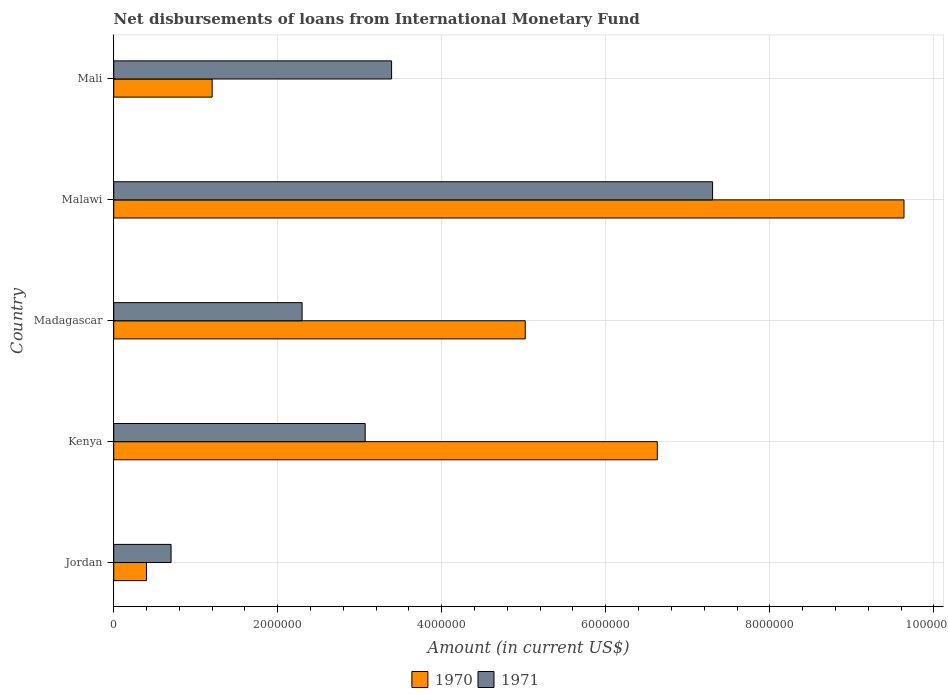How many groups of bars are there?
Make the answer very short. 5. Are the number of bars on each tick of the Y-axis equal?
Provide a succinct answer. Yes. How many bars are there on the 5th tick from the bottom?
Make the answer very short. 2. What is the label of the 1st group of bars from the top?
Give a very brief answer. Mali. In how many cases, is the number of bars for a given country not equal to the number of legend labels?
Ensure brevity in your answer.  0. What is the amount of loans disbursed in 1971 in Jordan?
Your response must be concise. 6.99e+05. Across all countries, what is the maximum amount of loans disbursed in 1970?
Offer a very short reply. 9.64e+06. Across all countries, what is the minimum amount of loans disbursed in 1971?
Your answer should be compact. 6.99e+05. In which country was the amount of loans disbursed in 1971 maximum?
Your answer should be compact. Malawi. In which country was the amount of loans disbursed in 1970 minimum?
Your answer should be compact. Jordan. What is the total amount of loans disbursed in 1971 in the graph?
Your answer should be compact. 1.68e+07. What is the difference between the amount of loans disbursed in 1971 in Jordan and that in Kenya?
Provide a short and direct response. -2.37e+06. What is the difference between the amount of loans disbursed in 1970 in Mali and the amount of loans disbursed in 1971 in Kenya?
Make the answer very short. -1.87e+06. What is the average amount of loans disbursed in 1971 per country?
Keep it short and to the point. 3.35e+06. What is the difference between the amount of loans disbursed in 1970 and amount of loans disbursed in 1971 in Madagascar?
Give a very brief answer. 2.72e+06. In how many countries, is the amount of loans disbursed in 1971 greater than 400000 US$?
Your response must be concise. 5. What is the ratio of the amount of loans disbursed in 1971 in Madagascar to that in Mali?
Your response must be concise. 0.68. What is the difference between the highest and the second highest amount of loans disbursed in 1971?
Keep it short and to the point. 3.91e+06. What is the difference between the highest and the lowest amount of loans disbursed in 1971?
Ensure brevity in your answer.  6.60e+06. Is the sum of the amount of loans disbursed in 1971 in Jordan and Madagascar greater than the maximum amount of loans disbursed in 1970 across all countries?
Make the answer very short. No. What does the 1st bar from the top in Jordan represents?
Ensure brevity in your answer.  1971. How many bars are there?
Your answer should be very brief. 10. Does the graph contain grids?
Offer a terse response. Yes. How are the legend labels stacked?
Ensure brevity in your answer.  Horizontal. What is the title of the graph?
Provide a short and direct response. Net disbursements of loans from International Monetary Fund. Does "1979" appear as one of the legend labels in the graph?
Offer a very short reply. No. What is the Amount (in current US$) in 1970 in Jordan?
Your response must be concise. 3.99e+05. What is the Amount (in current US$) of 1971 in Jordan?
Offer a very short reply. 6.99e+05. What is the Amount (in current US$) in 1970 in Kenya?
Ensure brevity in your answer.  6.63e+06. What is the Amount (in current US$) in 1971 in Kenya?
Offer a very short reply. 3.07e+06. What is the Amount (in current US$) in 1970 in Madagascar?
Provide a succinct answer. 5.02e+06. What is the Amount (in current US$) of 1971 in Madagascar?
Ensure brevity in your answer.  2.30e+06. What is the Amount (in current US$) of 1970 in Malawi?
Offer a terse response. 9.64e+06. What is the Amount (in current US$) of 1971 in Malawi?
Your answer should be compact. 7.30e+06. What is the Amount (in current US$) of 1970 in Mali?
Provide a succinct answer. 1.20e+06. What is the Amount (in current US$) in 1971 in Mali?
Give a very brief answer. 3.39e+06. Across all countries, what is the maximum Amount (in current US$) of 1970?
Ensure brevity in your answer.  9.64e+06. Across all countries, what is the maximum Amount (in current US$) in 1971?
Ensure brevity in your answer.  7.30e+06. Across all countries, what is the minimum Amount (in current US$) of 1970?
Provide a succinct answer. 3.99e+05. Across all countries, what is the minimum Amount (in current US$) of 1971?
Provide a short and direct response. 6.99e+05. What is the total Amount (in current US$) in 1970 in the graph?
Give a very brief answer. 2.29e+07. What is the total Amount (in current US$) of 1971 in the graph?
Your response must be concise. 1.68e+07. What is the difference between the Amount (in current US$) in 1970 in Jordan and that in Kenya?
Offer a very short reply. -6.23e+06. What is the difference between the Amount (in current US$) of 1971 in Jordan and that in Kenya?
Your response must be concise. -2.37e+06. What is the difference between the Amount (in current US$) in 1970 in Jordan and that in Madagascar?
Make the answer very short. -4.62e+06. What is the difference between the Amount (in current US$) of 1971 in Jordan and that in Madagascar?
Give a very brief answer. -1.60e+06. What is the difference between the Amount (in current US$) of 1970 in Jordan and that in Malawi?
Your answer should be compact. -9.24e+06. What is the difference between the Amount (in current US$) in 1971 in Jordan and that in Malawi?
Keep it short and to the point. -6.60e+06. What is the difference between the Amount (in current US$) in 1970 in Jordan and that in Mali?
Keep it short and to the point. -8.01e+05. What is the difference between the Amount (in current US$) of 1971 in Jordan and that in Mali?
Your answer should be compact. -2.69e+06. What is the difference between the Amount (in current US$) of 1970 in Kenya and that in Madagascar?
Provide a succinct answer. 1.61e+06. What is the difference between the Amount (in current US$) of 1971 in Kenya and that in Madagascar?
Offer a terse response. 7.69e+05. What is the difference between the Amount (in current US$) in 1970 in Kenya and that in Malawi?
Provide a short and direct response. -3.01e+06. What is the difference between the Amount (in current US$) in 1971 in Kenya and that in Malawi?
Provide a succinct answer. -4.24e+06. What is the difference between the Amount (in current US$) of 1970 in Kenya and that in Mali?
Provide a succinct answer. 5.43e+06. What is the difference between the Amount (in current US$) in 1971 in Kenya and that in Mali?
Make the answer very short. -3.22e+05. What is the difference between the Amount (in current US$) of 1970 in Madagascar and that in Malawi?
Provide a succinct answer. -4.62e+06. What is the difference between the Amount (in current US$) of 1971 in Madagascar and that in Malawi?
Your answer should be compact. -5.00e+06. What is the difference between the Amount (in current US$) of 1970 in Madagascar and that in Mali?
Provide a short and direct response. 3.82e+06. What is the difference between the Amount (in current US$) of 1971 in Madagascar and that in Mali?
Provide a short and direct response. -1.09e+06. What is the difference between the Amount (in current US$) of 1970 in Malawi and that in Mali?
Give a very brief answer. 8.44e+06. What is the difference between the Amount (in current US$) in 1971 in Malawi and that in Mali?
Provide a short and direct response. 3.91e+06. What is the difference between the Amount (in current US$) of 1970 in Jordan and the Amount (in current US$) of 1971 in Kenya?
Ensure brevity in your answer.  -2.67e+06. What is the difference between the Amount (in current US$) in 1970 in Jordan and the Amount (in current US$) in 1971 in Madagascar?
Offer a very short reply. -1.90e+06. What is the difference between the Amount (in current US$) in 1970 in Jordan and the Amount (in current US$) in 1971 in Malawi?
Keep it short and to the point. -6.90e+06. What is the difference between the Amount (in current US$) in 1970 in Jordan and the Amount (in current US$) in 1971 in Mali?
Your answer should be compact. -2.99e+06. What is the difference between the Amount (in current US$) of 1970 in Kenya and the Amount (in current US$) of 1971 in Madagascar?
Offer a very short reply. 4.33e+06. What is the difference between the Amount (in current US$) in 1970 in Kenya and the Amount (in current US$) in 1971 in Malawi?
Your response must be concise. -6.74e+05. What is the difference between the Amount (in current US$) in 1970 in Kenya and the Amount (in current US$) in 1971 in Mali?
Your answer should be compact. 3.24e+06. What is the difference between the Amount (in current US$) of 1970 in Madagascar and the Amount (in current US$) of 1971 in Malawi?
Keep it short and to the point. -2.28e+06. What is the difference between the Amount (in current US$) of 1970 in Madagascar and the Amount (in current US$) of 1971 in Mali?
Your answer should be very brief. 1.63e+06. What is the difference between the Amount (in current US$) in 1970 in Malawi and the Amount (in current US$) in 1971 in Mali?
Give a very brief answer. 6.25e+06. What is the average Amount (in current US$) of 1970 per country?
Offer a very short reply. 4.58e+06. What is the average Amount (in current US$) in 1971 per country?
Your response must be concise. 3.35e+06. What is the difference between the Amount (in current US$) in 1970 and Amount (in current US$) in 1971 in Jordan?
Keep it short and to the point. -3.00e+05. What is the difference between the Amount (in current US$) in 1970 and Amount (in current US$) in 1971 in Kenya?
Your answer should be very brief. 3.56e+06. What is the difference between the Amount (in current US$) in 1970 and Amount (in current US$) in 1971 in Madagascar?
Keep it short and to the point. 2.72e+06. What is the difference between the Amount (in current US$) of 1970 and Amount (in current US$) of 1971 in Malawi?
Offer a terse response. 2.33e+06. What is the difference between the Amount (in current US$) in 1970 and Amount (in current US$) in 1971 in Mali?
Make the answer very short. -2.19e+06. What is the ratio of the Amount (in current US$) of 1970 in Jordan to that in Kenya?
Your answer should be very brief. 0.06. What is the ratio of the Amount (in current US$) in 1971 in Jordan to that in Kenya?
Offer a terse response. 0.23. What is the ratio of the Amount (in current US$) in 1970 in Jordan to that in Madagascar?
Your answer should be compact. 0.08. What is the ratio of the Amount (in current US$) in 1971 in Jordan to that in Madagascar?
Offer a terse response. 0.3. What is the ratio of the Amount (in current US$) in 1970 in Jordan to that in Malawi?
Make the answer very short. 0.04. What is the ratio of the Amount (in current US$) in 1971 in Jordan to that in Malawi?
Your answer should be compact. 0.1. What is the ratio of the Amount (in current US$) in 1970 in Jordan to that in Mali?
Your answer should be compact. 0.33. What is the ratio of the Amount (in current US$) in 1971 in Jordan to that in Mali?
Your response must be concise. 0.21. What is the ratio of the Amount (in current US$) in 1970 in Kenya to that in Madagascar?
Ensure brevity in your answer.  1.32. What is the ratio of the Amount (in current US$) of 1971 in Kenya to that in Madagascar?
Your answer should be compact. 1.33. What is the ratio of the Amount (in current US$) of 1970 in Kenya to that in Malawi?
Give a very brief answer. 0.69. What is the ratio of the Amount (in current US$) in 1971 in Kenya to that in Malawi?
Your answer should be very brief. 0.42. What is the ratio of the Amount (in current US$) in 1970 in Kenya to that in Mali?
Give a very brief answer. 5.52. What is the ratio of the Amount (in current US$) in 1971 in Kenya to that in Mali?
Keep it short and to the point. 0.91. What is the ratio of the Amount (in current US$) in 1970 in Madagascar to that in Malawi?
Provide a short and direct response. 0.52. What is the ratio of the Amount (in current US$) of 1971 in Madagascar to that in Malawi?
Provide a succinct answer. 0.31. What is the ratio of the Amount (in current US$) of 1970 in Madagascar to that in Mali?
Your response must be concise. 4.18. What is the ratio of the Amount (in current US$) of 1971 in Madagascar to that in Mali?
Keep it short and to the point. 0.68. What is the ratio of the Amount (in current US$) of 1970 in Malawi to that in Mali?
Your answer should be very brief. 8.03. What is the ratio of the Amount (in current US$) of 1971 in Malawi to that in Mali?
Provide a succinct answer. 2.16. What is the difference between the highest and the second highest Amount (in current US$) in 1970?
Give a very brief answer. 3.01e+06. What is the difference between the highest and the second highest Amount (in current US$) of 1971?
Your answer should be very brief. 3.91e+06. What is the difference between the highest and the lowest Amount (in current US$) of 1970?
Your answer should be very brief. 9.24e+06. What is the difference between the highest and the lowest Amount (in current US$) of 1971?
Offer a very short reply. 6.60e+06. 